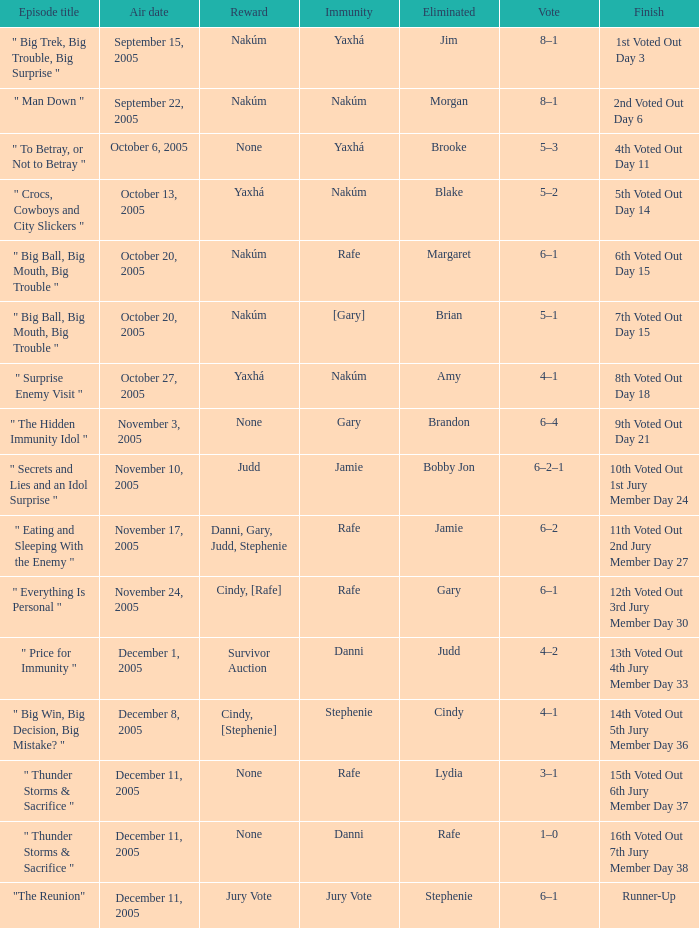How many awards are present for air date october 6, 2005? None. 